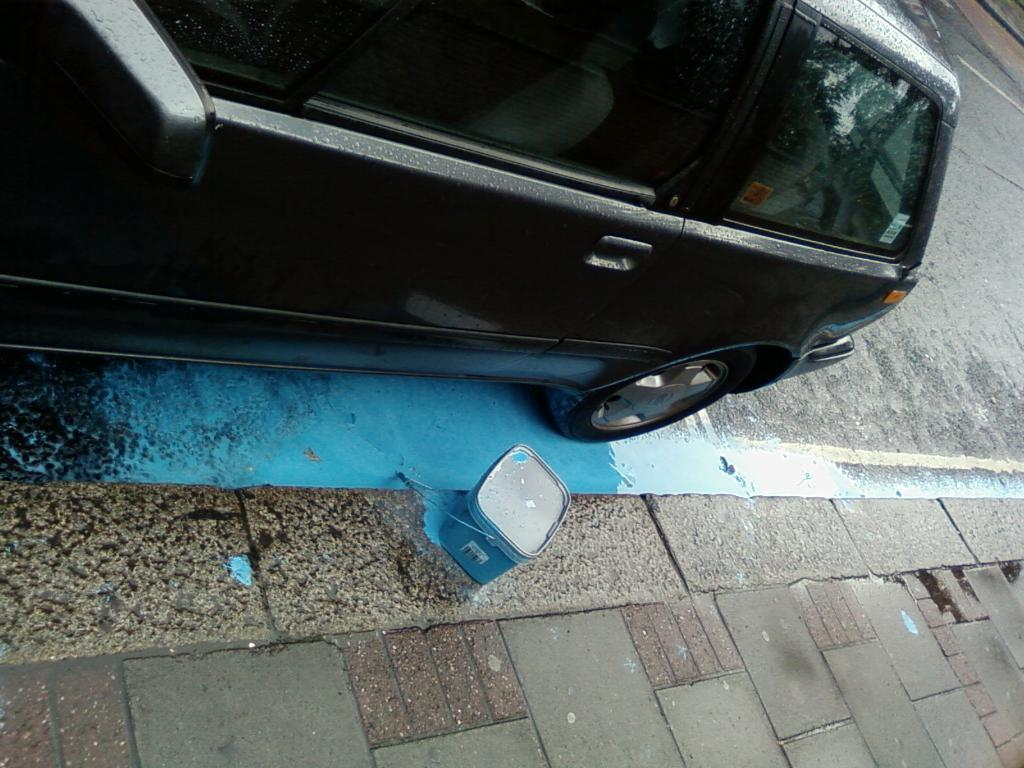What is the main subject of the image? There is a car in the image. What color is the car? The car is black. Where is the car located in the image? The car is on the road. What else can be seen in the middle of the image? There is a box in the middle of the image. How many circles can be seen in the image? There are no circles present in the image. Is the dog resting on the car in the image? There is no dog present in the image. 